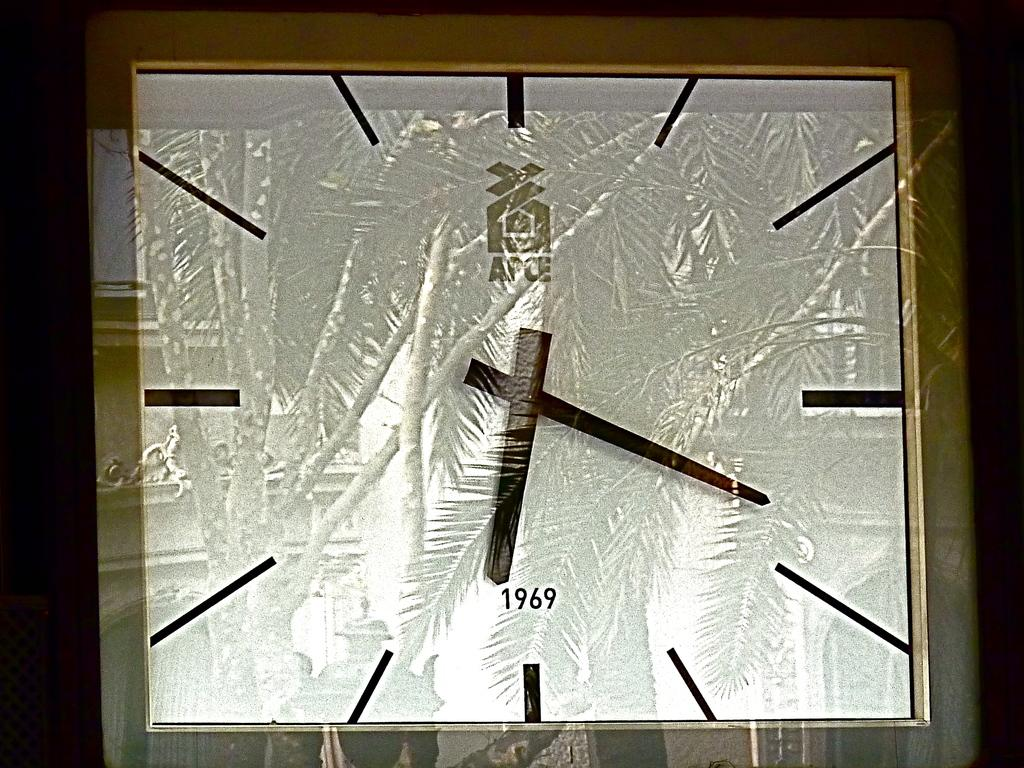What object can be seen in the image? There is a watch in the image. What information is displayed on the watch? The year is displayed on the watch in black color. Is there a patch of crayons visible in the image? No, there is no patch of crayons present in the image. 